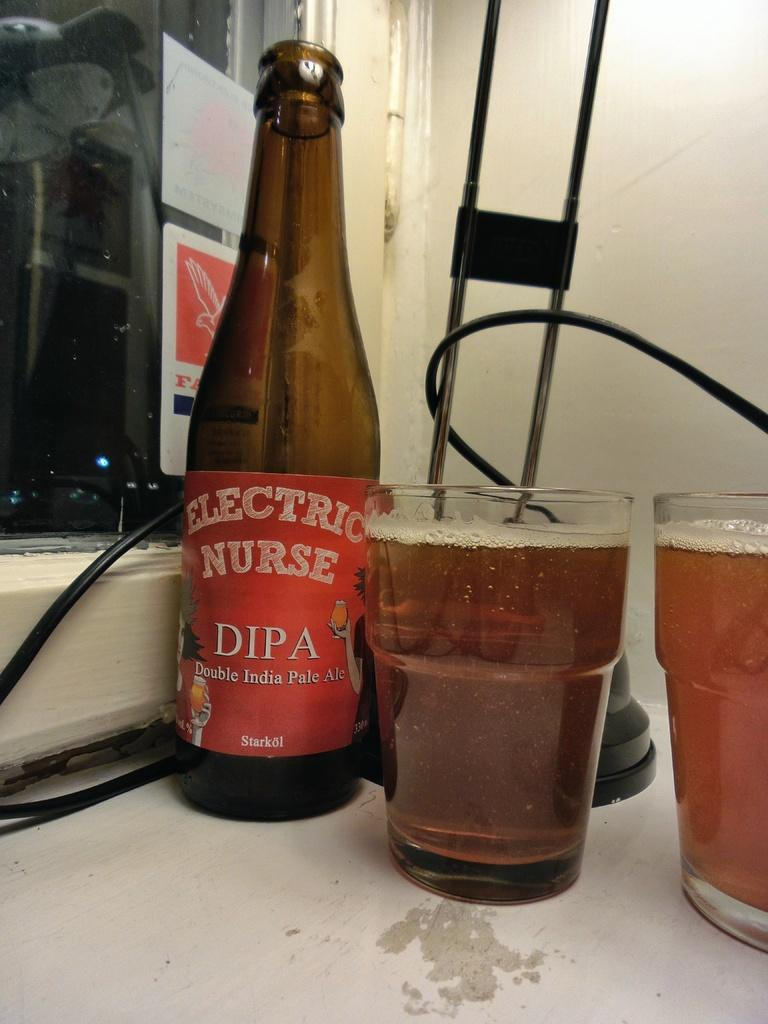<image>
Create a compact narrative representing the image presented. An Electric Nurse Double IPA bottle sits next to two full glasses. 